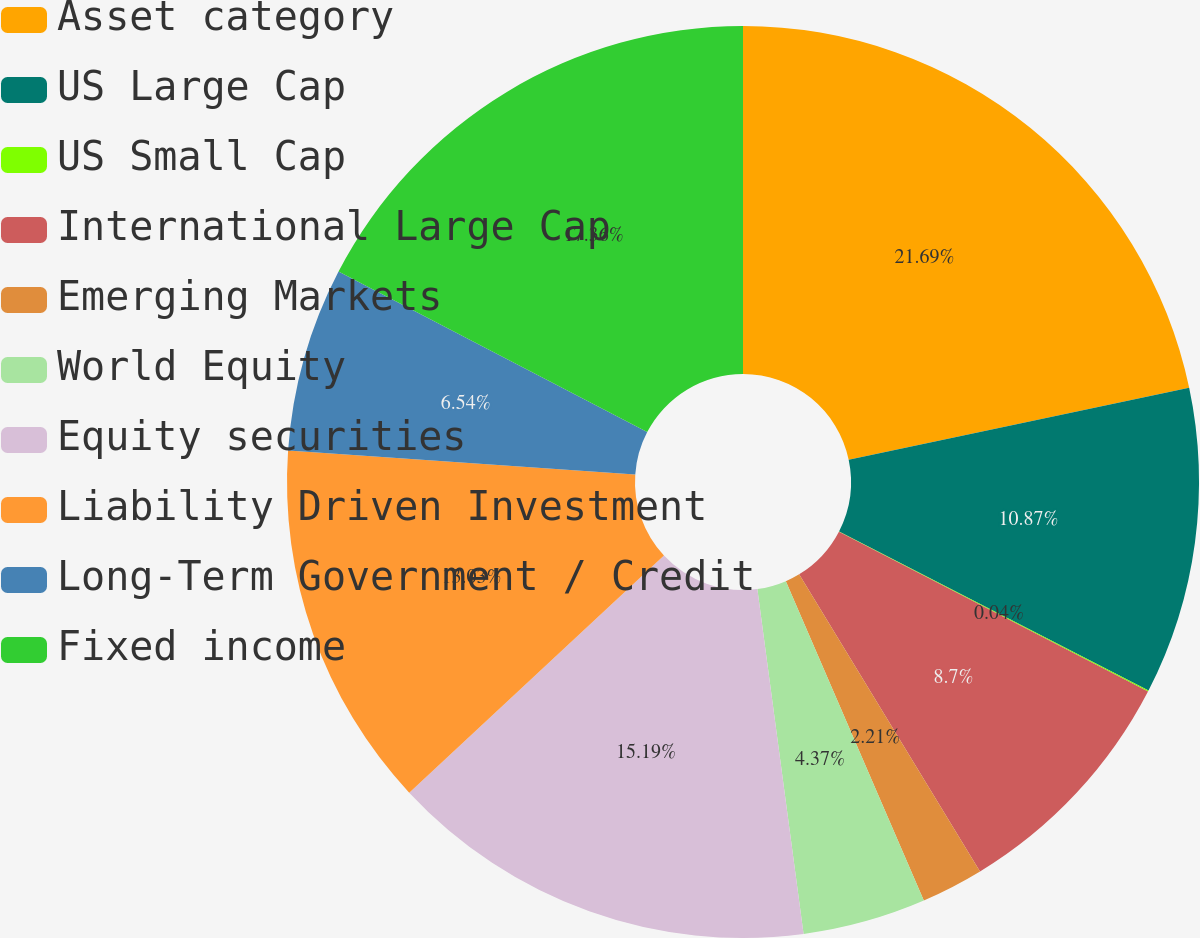Convert chart. <chart><loc_0><loc_0><loc_500><loc_500><pie_chart><fcel>Asset category<fcel>US Large Cap<fcel>US Small Cap<fcel>International Large Cap<fcel>Emerging Markets<fcel>World Equity<fcel>Equity securities<fcel>Liability Driven Investment<fcel>Long-Term Government / Credit<fcel>Fixed income<nl><fcel>21.69%<fcel>10.87%<fcel>0.04%<fcel>8.7%<fcel>2.21%<fcel>4.37%<fcel>15.19%<fcel>13.03%<fcel>6.54%<fcel>17.36%<nl></chart> 